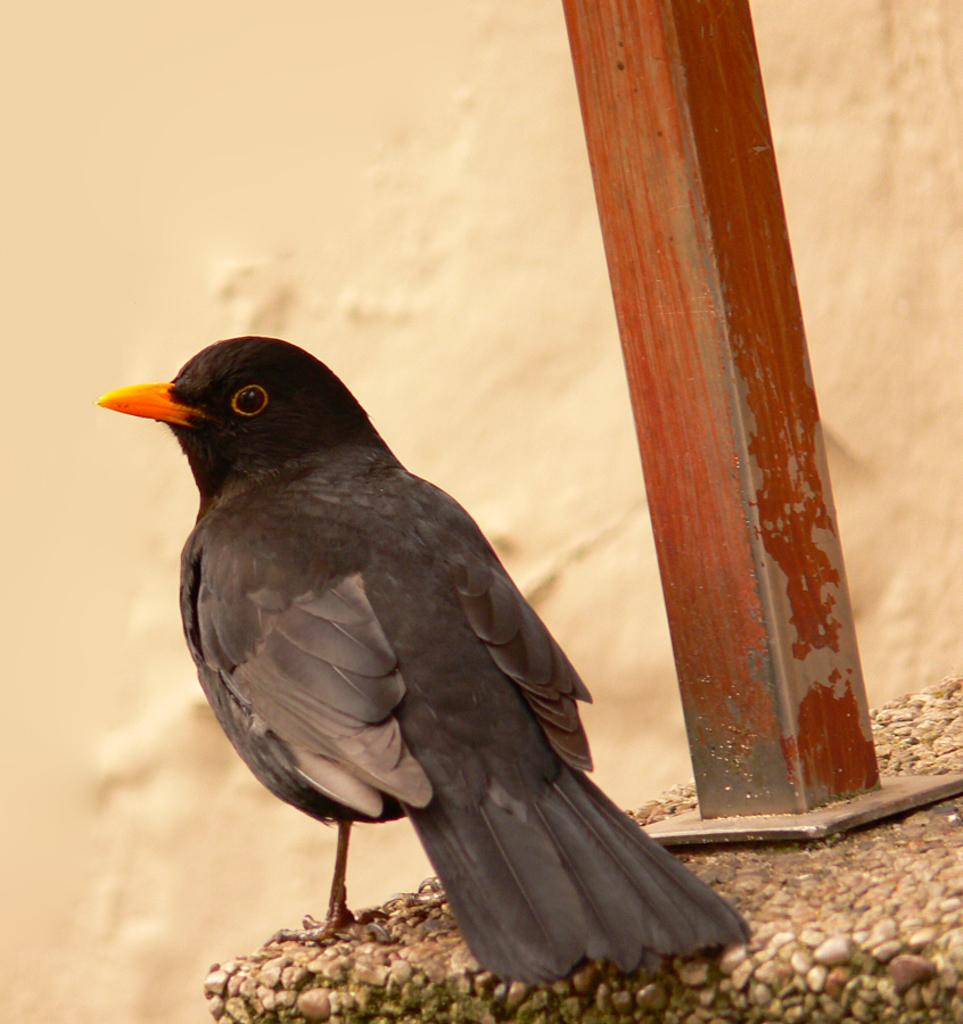What type of animal can be seen in the image? There is a bird in the image. What is the bird perched on? The bird is perched on an iron pole. Where is the iron pole located? The iron pole is on a rock. What can be seen in the background of the image? There is a wall visible in the background of the image. What type of meal is being prepared in the image? There is no meal being prepared in the image; it features a bird perched on an iron pole on a rock with a wall visible in the background. How does the knee of the bird look like in the image? There is no visible knee of the bird in the image, as birds do not have knees like humans. 